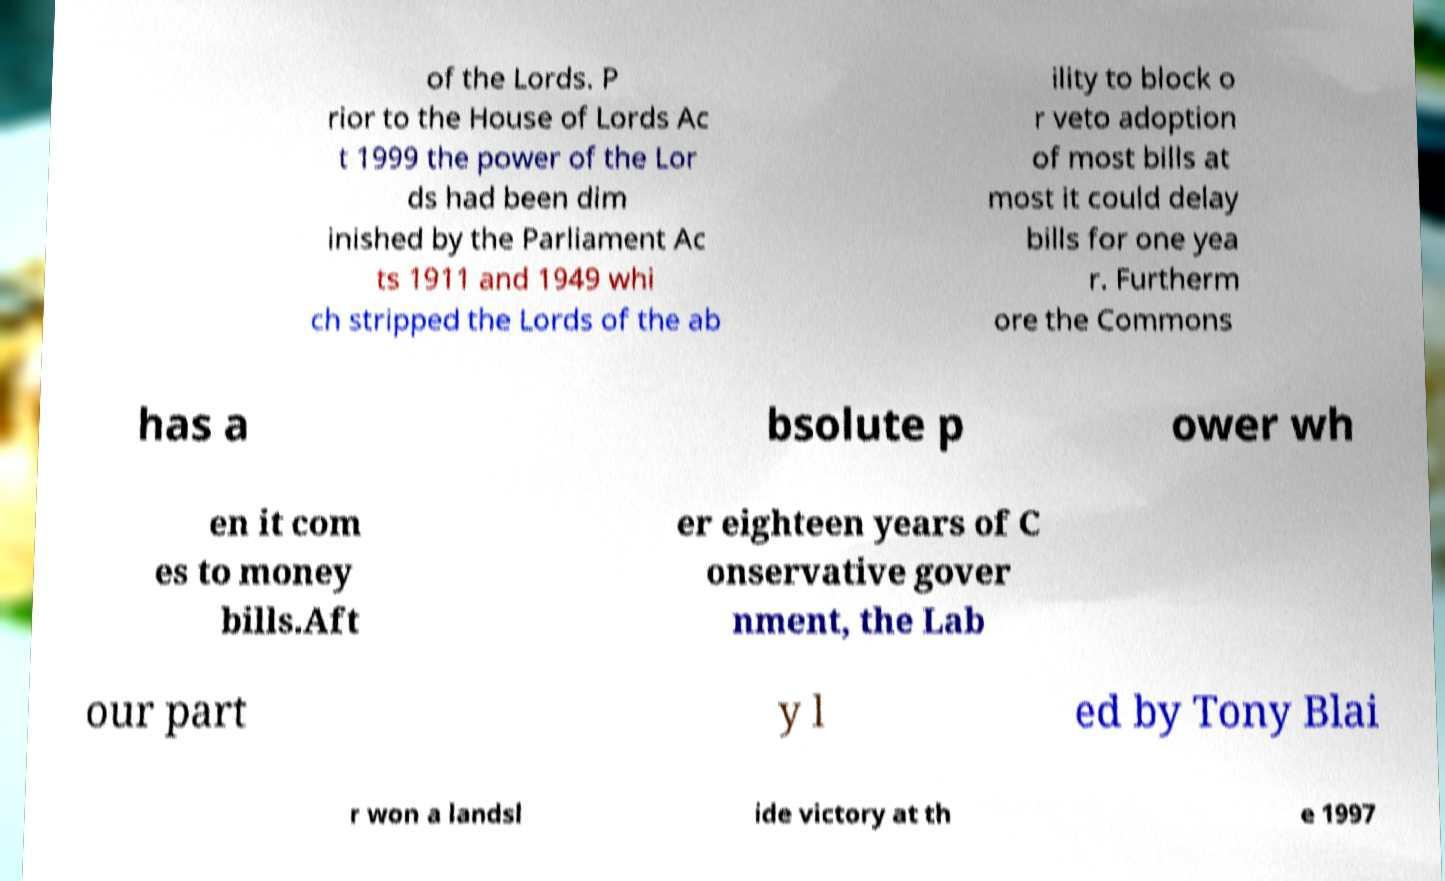I need the written content from this picture converted into text. Can you do that? of the Lords. P rior to the House of Lords Ac t 1999 the power of the Lor ds had been dim inished by the Parliament Ac ts 1911 and 1949 whi ch stripped the Lords of the ab ility to block o r veto adoption of most bills at most it could delay bills for one yea r. Furtherm ore the Commons has a bsolute p ower wh en it com es to money bills.Aft er eighteen years of C onservative gover nment, the Lab our part y l ed by Tony Blai r won a landsl ide victory at th e 1997 